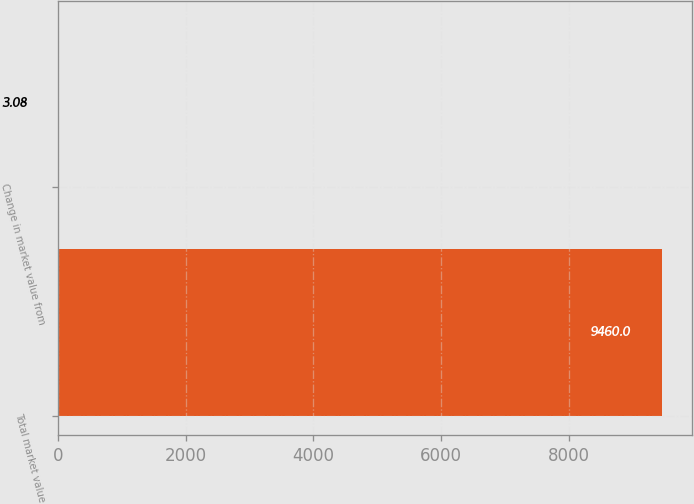Convert chart. <chart><loc_0><loc_0><loc_500><loc_500><bar_chart><fcel>Total market value<fcel>Change in market value from<nl><fcel>9460<fcel>3.08<nl></chart> 